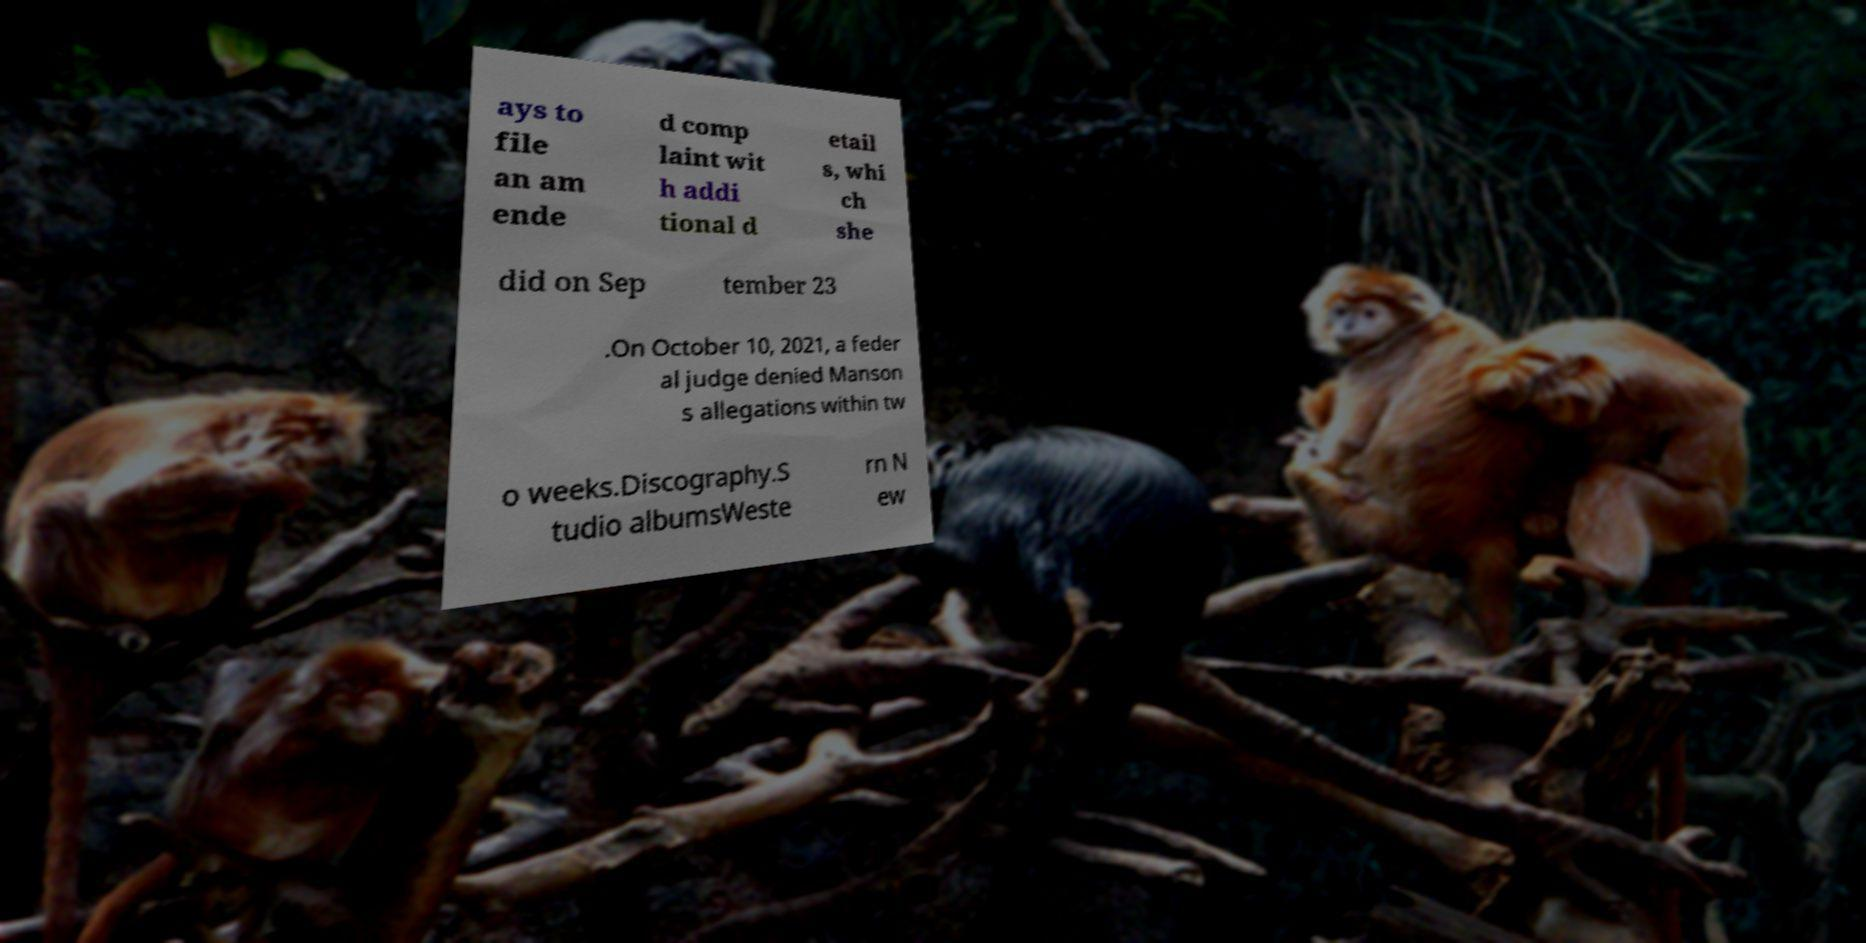There's text embedded in this image that I need extracted. Can you transcribe it verbatim? ays to file an am ende d comp laint wit h addi tional d etail s, whi ch she did on Sep tember 23 .On October 10, 2021, a feder al judge denied Manson s allegations within tw o weeks.Discography.S tudio albumsWeste rn N ew 